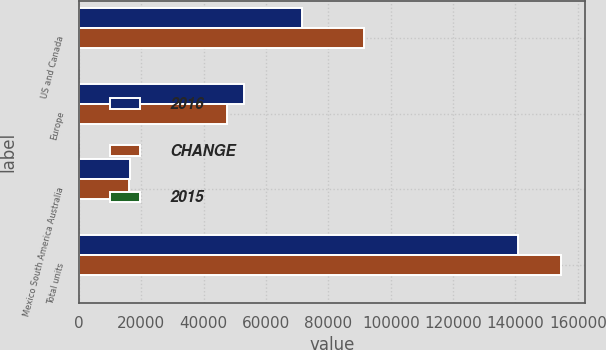Convert chart. <chart><loc_0><loc_0><loc_500><loc_500><stacked_bar_chart><ecel><fcel>US and Canada<fcel>Europe<fcel>Mexico South America Australia<fcel>Total units<nl><fcel>2016<fcel>71500<fcel>53000<fcel>16400<fcel>140900<nl><fcel>CHANGE<fcel>91300<fcel>47400<fcel>16000<fcel>154700<nl><fcel>2015<fcel>22<fcel>12<fcel>3<fcel>9<nl></chart> 